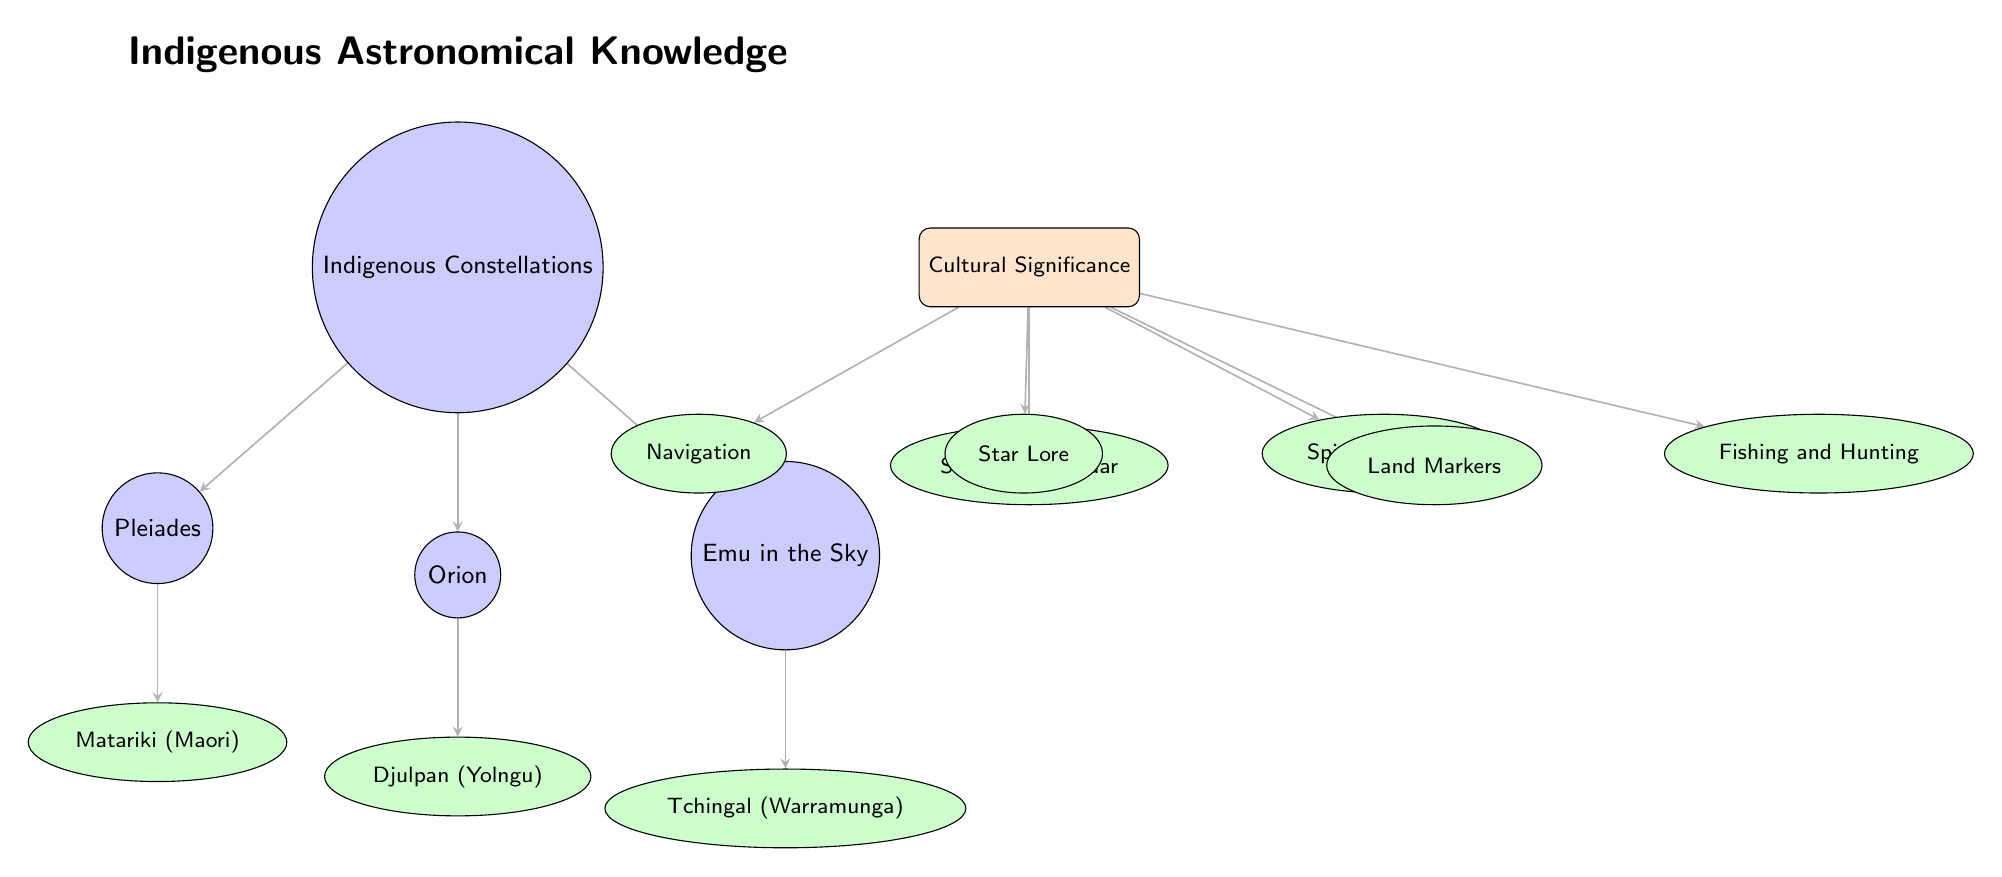What are the three indigenous constellations depicted in the diagram? The diagram lists three indigenous constellations: Pleiades, Orion, and Emu in the Sky. These are shown as main nodes directly connected to the Indigenous Constellations node.
Answer: Pleiades, Orion, Emu in the Sky What cultural significance node is located directly below the main cultural significance node? The node directly below the cultural significance node is Navigation, indicating one aspect of the cultural importance of the constellations.
Answer: Navigation How many total cultural significance nodes can be found in the diagram? The diagram presents a total of six cultural significance nodes: Navigation, Seasonal Calendar, Spiritual Beliefs, Star Lore, Land Markers, and Fishing and Hunting. This count is derived from the visible sub-nodes linked to the Cultural Significance node.
Answer: Six Which constellation is associated with the Maori culture? The constellation associated with the Maori culture is Matariki, which is depicted as a sub-node directly linked to the Pleiades node.
Answer: Matariki What is the cultural belief associated with the Aboriginal constellation? The cultural belief linked with the Aboriginal constellation, Djulpan, is recognized within the diagram as it is indicated beneath the Orion node.
Answer: Djulpan Which indigenous constellation is connected to Tchingal in the diagram? Tchingal is connected to the Emu in the Sky constellation, as shown by the arrow linking the Emu node to the Australian sub-node.
Answer: Tchingal What type of diagram is used to represent the indigenous astronomical knowledge? The diagram represents the indigenous astronomical knowledge as a hierarchical relationship among constellations and their cultural significance using nodes and edges.
Answer: Hierarchical Diagram What is the color used for cultural significance nodes in the diagram? The cultural significance nodes are colored orange, as indicated by their fill in the diagram, setting them apart visually from other nodes.
Answer: Orange 